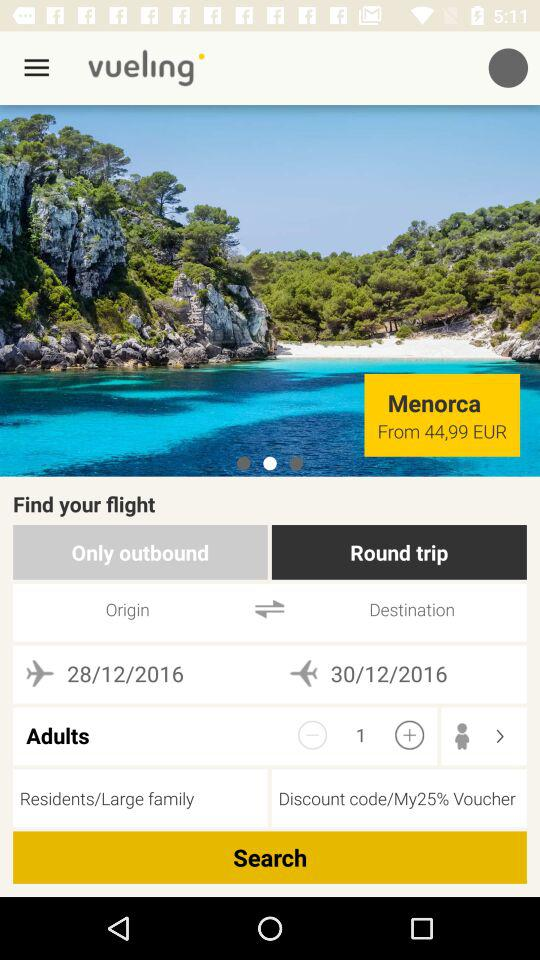What is the starting price of a ticket to Menorca in EUR? The starting price of a ticket to Menorca in EUR starts from 44,99 EUR. 